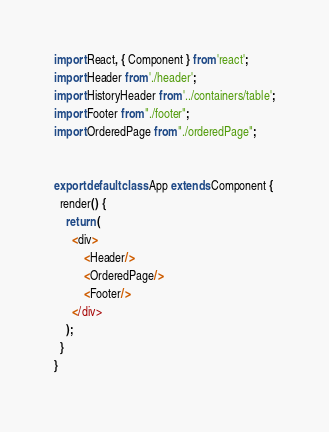<code> <loc_0><loc_0><loc_500><loc_500><_JavaScript_>import React, { Component } from 'react';
import Header from './header';
import HistoryHeader from '../containers/table';
import Footer from "./footer";
import OrderedPage from "./orderedPage";


export default class App extends Component {
  render() {
    return (
      <div>
          <Header/>
          <OrderedPage/>
          <Footer/>
      </div>
    );
  }
}
</code> 